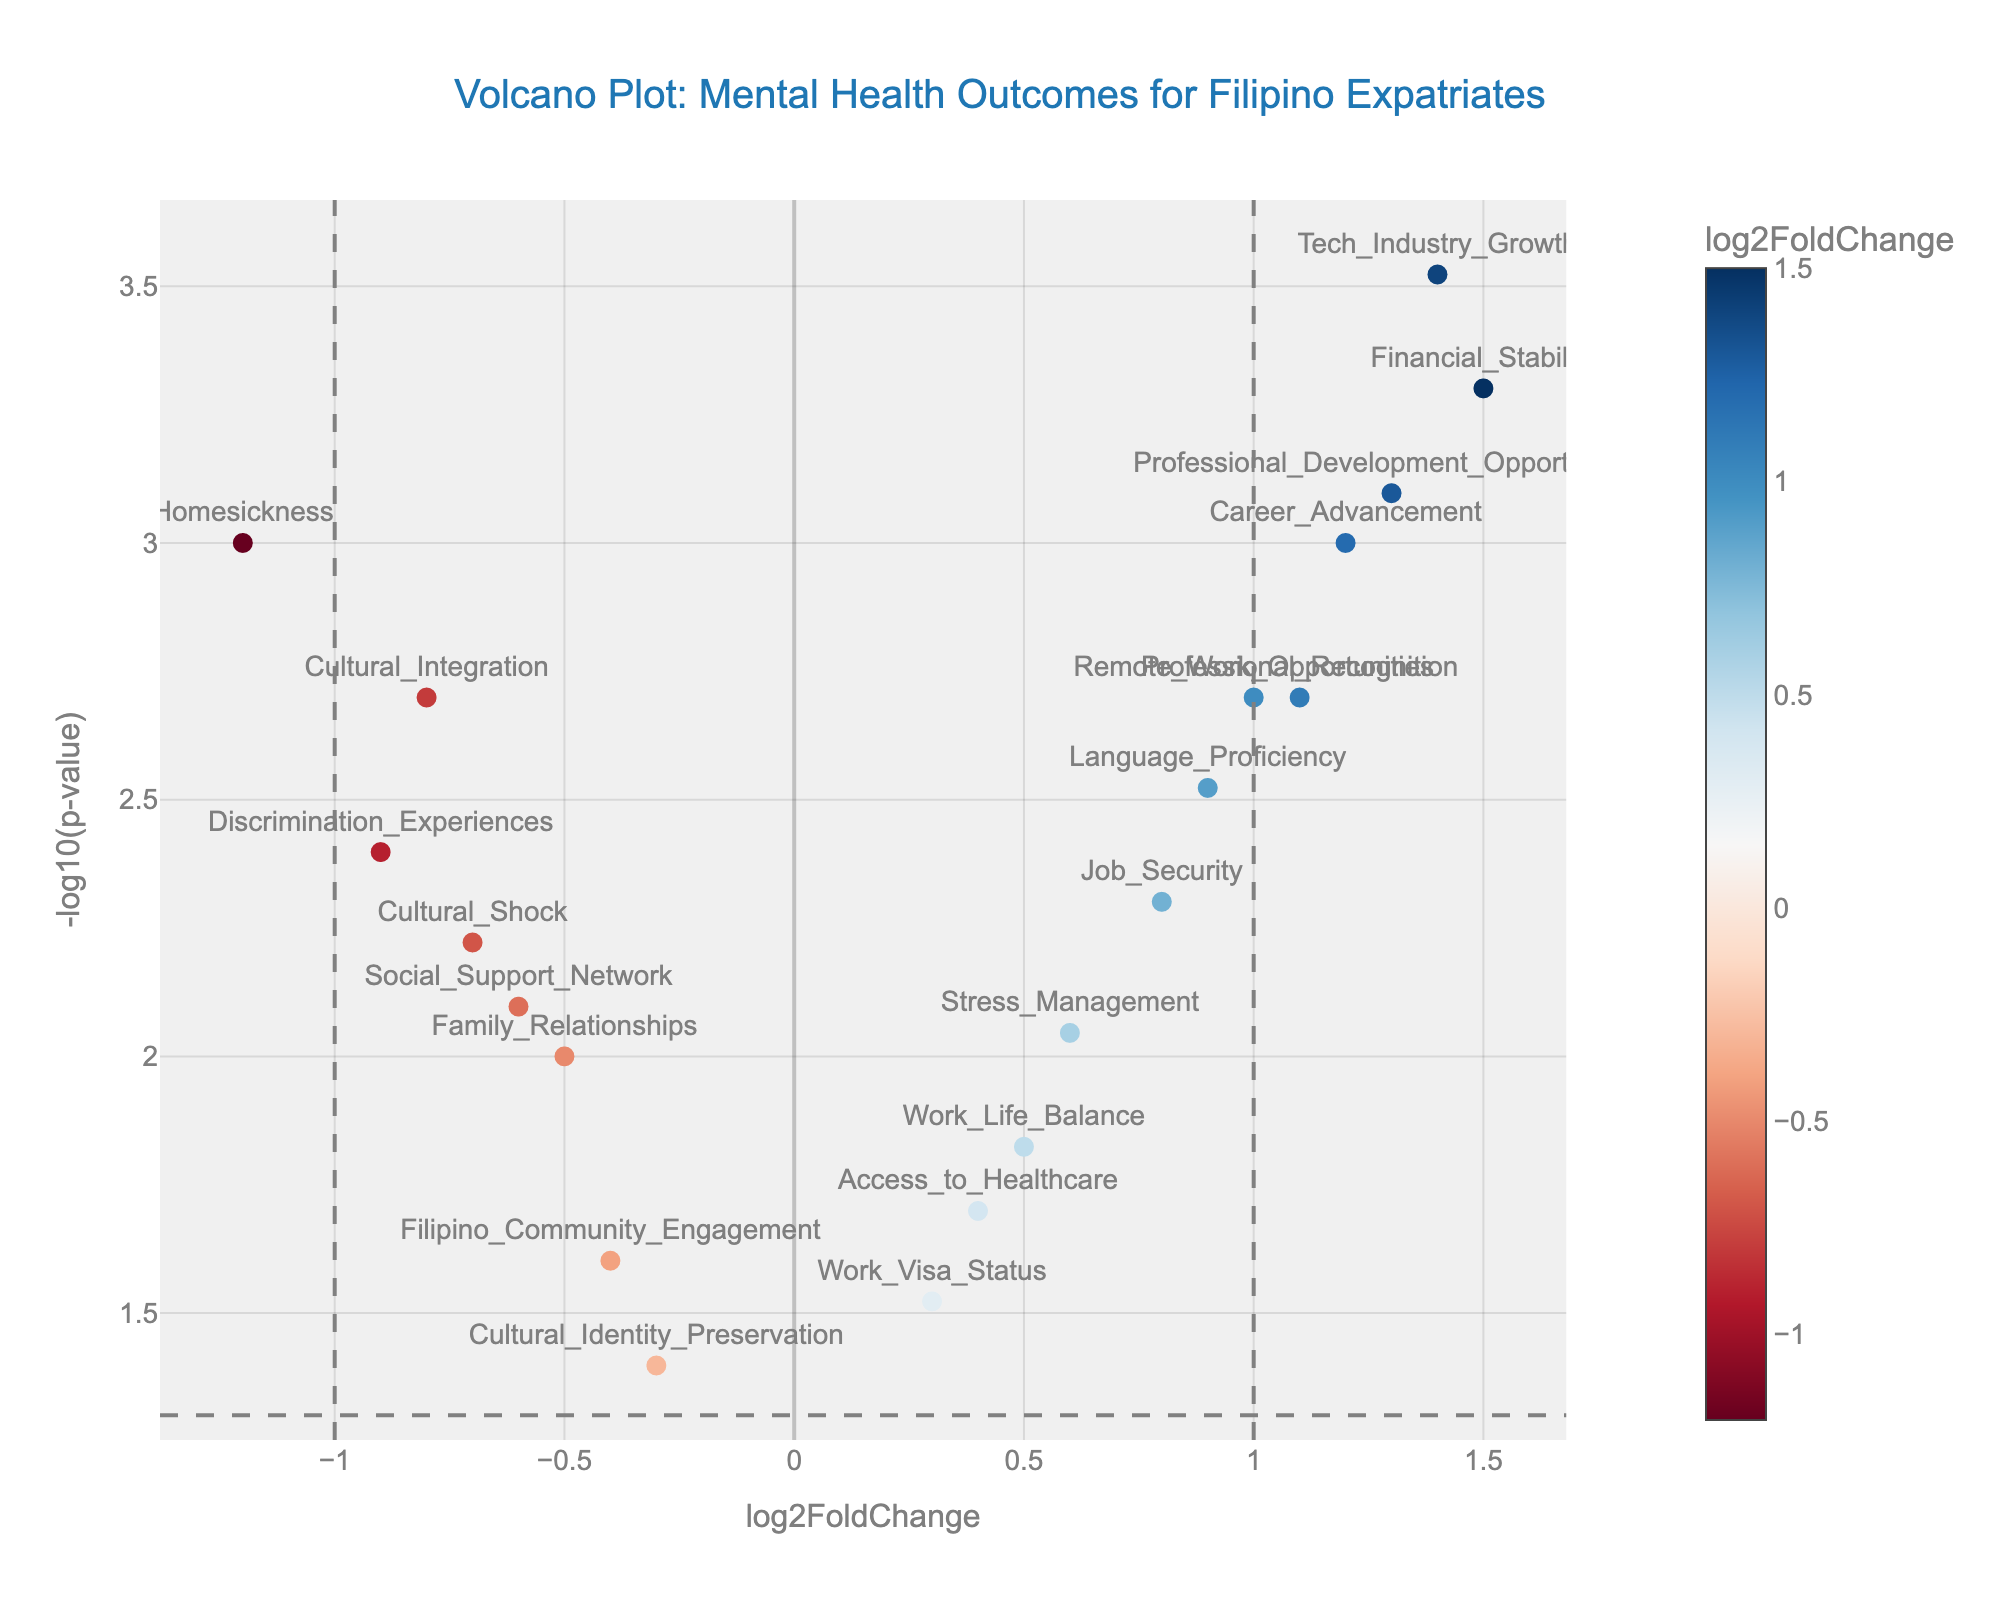What is the title of the plot? The title is usually located at the top of the plot and provides a summary of what the plot is about. In this case, we can read the title directly from the provided information.
Answer: "Volcano Plot: Mental Health Outcomes for Filipino Expatriates" What is represented on the x-axis? The x-axis of the plot is usually labeled directly below it, indicating what is being measured. In this case, "log2FoldChange" is the label on the x-axis.
Answer: log2FoldChange What does the y-axis represent? The y-axis is labeled on the side of the plot, indicating what is being measured. Here, we see that it represents "-log10(p-value)".
Answer: -log10(p-value) Which factor has the highest positive log2FoldChange? By examining the data points on the right side of the plot, the factor with the highest positive log2FoldChange is the furthest to the right. In this case, it is "Financial_Stability" with a log2FoldChange of 1.5.
Answer: Financial_Stability Which factor has the lowest negative log2FoldChange? The factor with the lowest negative log2FoldChange will be the furthest to the left on the plot. Here, "Homesickness" has the lowest value at -1.2.
Answer: Homesickness What is the significance threshold line on the y-axis for p-values? The significance threshold is indicated by a horizontal line on the y-axis at -log10(0.05). Calculating this value gives approximately 1.3010.
Answer: 1.3010 How many factors have a p-value less than 0.01? A p-value less than 0.01 corresponds to data points above -log10(0.01) on the y-axis. By counting the points above this line, we find there are 11 factors.
Answer: 11 Which factor shows significant positive changes in career-related outcomes? Factors with significant positive changes will have a log2FoldChange greater than 1 and a p-value less than 0.05. "Career_Advancement," "Tech_Industry_Growth," and "Professional_Development_Opportunities" meet these criteria.
Answer: Career_Advancement, Tech_Industry_Growth, and Professional_Development_Opportunities What is the log2FoldChange of the factor "Remote_Work_Opportunities"? The log2FoldChange for "Remote_Work_Opportunities" can be found by locating its data point in the plot and referring to the hover text. It is 1.0.
Answer: 1.0 Which factors are associated with negative mental health outcomes, based on their log2FoldChange and significance? Negative mental health outcomes would have a negative log2FoldChange and a significant p-value (below 0.05). These factors are: "Cultural_Integration," "Social_Support_Network," "Homesickness," "Discrimination_Experiences," "Family_Relationships," "Cultural_Shock," and "Filipino_Community_Engagement."
Answer: Cultural_Integration, Social_Support_Network, Homesickness, Discrimination_Experiences, Family_Relationships, Cultural_Shock, Filipino_Community_Engagement 